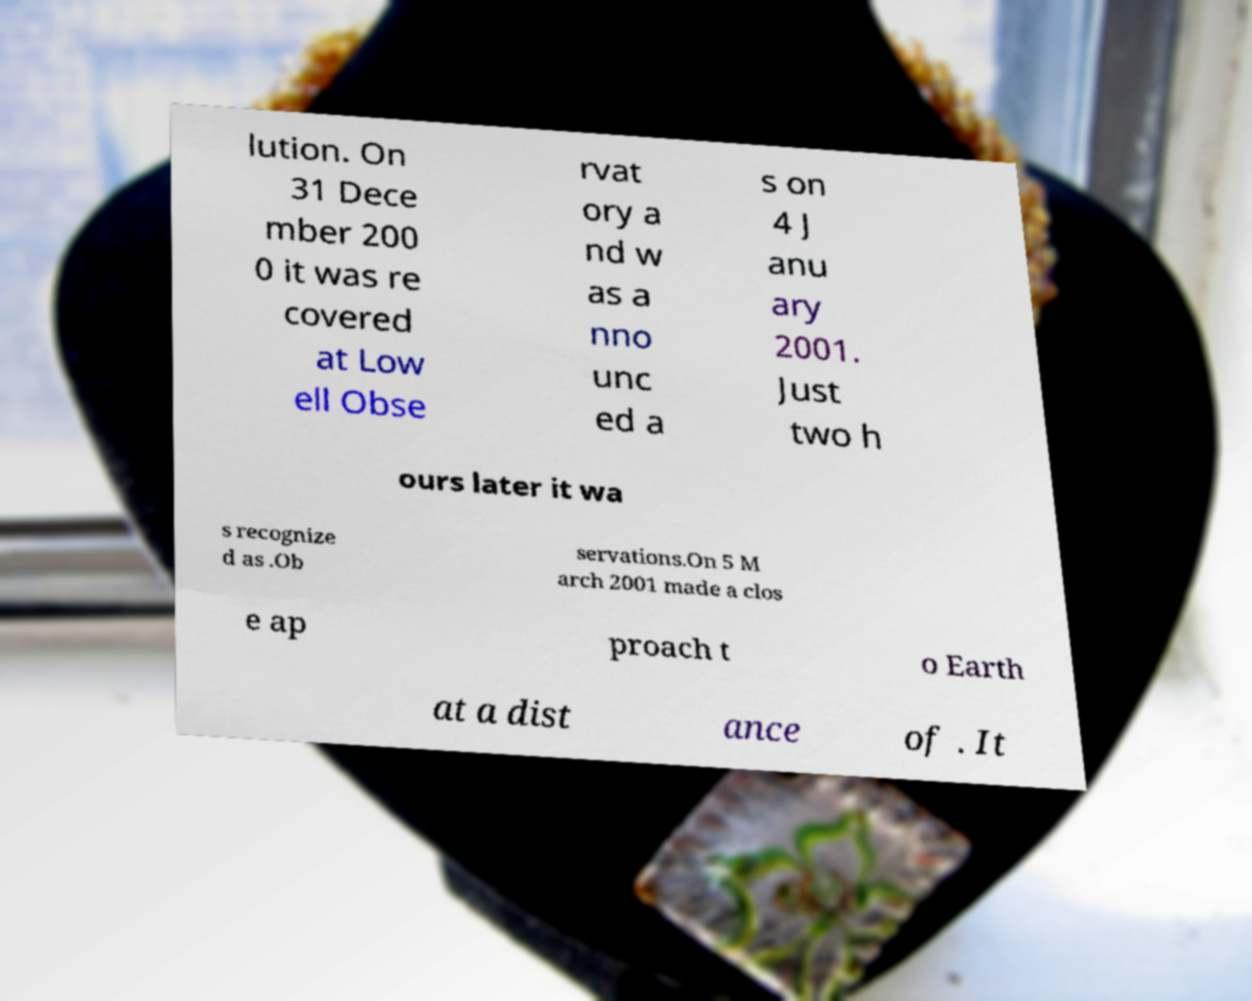I need the written content from this picture converted into text. Can you do that? lution. On 31 Dece mber 200 0 it was re covered at Low ell Obse rvat ory a nd w as a nno unc ed a s on 4 J anu ary 2001. Just two h ours later it wa s recognize d as .Ob servations.On 5 M arch 2001 made a clos e ap proach t o Earth at a dist ance of . It 